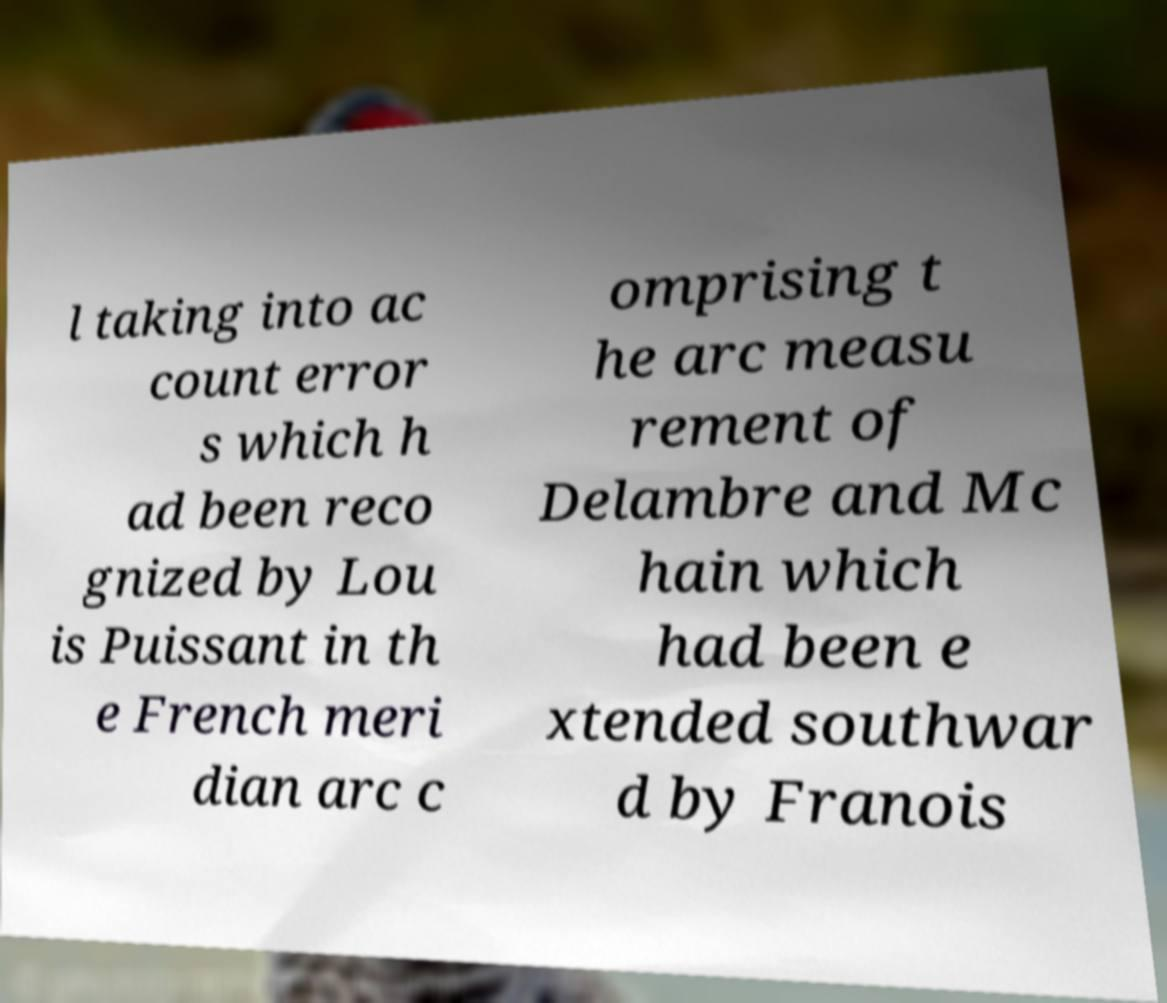For documentation purposes, I need the text within this image transcribed. Could you provide that? l taking into ac count error s which h ad been reco gnized by Lou is Puissant in th e French meri dian arc c omprising t he arc measu rement of Delambre and Mc hain which had been e xtended southwar d by Franois 